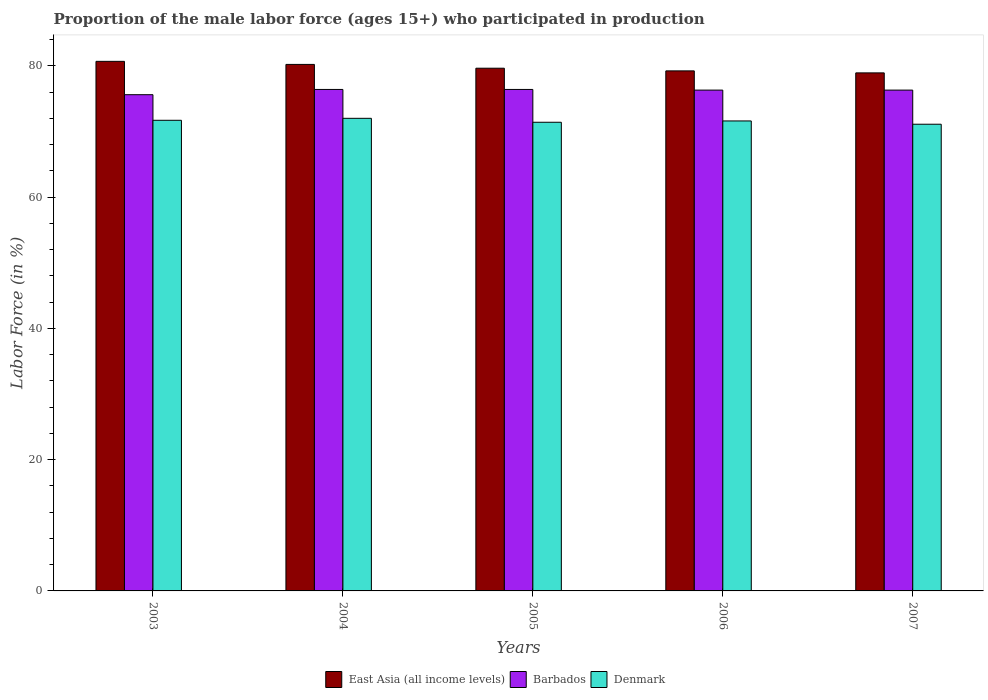How many different coloured bars are there?
Your response must be concise. 3. Are the number of bars per tick equal to the number of legend labels?
Provide a succinct answer. Yes. Are the number of bars on each tick of the X-axis equal?
Provide a succinct answer. Yes. How many bars are there on the 1st tick from the right?
Make the answer very short. 3. What is the label of the 1st group of bars from the left?
Keep it short and to the point. 2003. What is the proportion of the male labor force who participated in production in East Asia (all income levels) in 2004?
Offer a terse response. 80.21. Across all years, what is the maximum proportion of the male labor force who participated in production in East Asia (all income levels)?
Your response must be concise. 80.68. Across all years, what is the minimum proportion of the male labor force who participated in production in Denmark?
Offer a very short reply. 71.1. In which year was the proportion of the male labor force who participated in production in East Asia (all income levels) maximum?
Provide a succinct answer. 2003. What is the total proportion of the male labor force who participated in production in Barbados in the graph?
Your response must be concise. 381. What is the difference between the proportion of the male labor force who participated in production in East Asia (all income levels) in 2004 and that in 2005?
Your answer should be compact. 0.58. What is the difference between the proportion of the male labor force who participated in production in Denmark in 2003 and the proportion of the male labor force who participated in production in East Asia (all income levels) in 2006?
Your response must be concise. -7.53. What is the average proportion of the male labor force who participated in production in East Asia (all income levels) per year?
Give a very brief answer. 79.73. In the year 2004, what is the difference between the proportion of the male labor force who participated in production in East Asia (all income levels) and proportion of the male labor force who participated in production in Barbados?
Keep it short and to the point. 3.81. What is the ratio of the proportion of the male labor force who participated in production in East Asia (all income levels) in 2005 to that in 2007?
Provide a succinct answer. 1.01. Is the proportion of the male labor force who participated in production in East Asia (all income levels) in 2004 less than that in 2005?
Make the answer very short. No. What is the difference between the highest and the second highest proportion of the male labor force who participated in production in Barbados?
Your response must be concise. 0. What is the difference between the highest and the lowest proportion of the male labor force who participated in production in Barbados?
Provide a short and direct response. 0.8. Is the sum of the proportion of the male labor force who participated in production in East Asia (all income levels) in 2005 and 2007 greater than the maximum proportion of the male labor force who participated in production in Barbados across all years?
Give a very brief answer. Yes. How many years are there in the graph?
Provide a short and direct response. 5. Does the graph contain grids?
Give a very brief answer. No. Where does the legend appear in the graph?
Provide a succinct answer. Bottom center. How many legend labels are there?
Your response must be concise. 3. What is the title of the graph?
Provide a succinct answer. Proportion of the male labor force (ages 15+) who participated in production. What is the label or title of the Y-axis?
Keep it short and to the point. Labor Force (in %). What is the Labor Force (in %) of East Asia (all income levels) in 2003?
Keep it short and to the point. 80.68. What is the Labor Force (in %) of Barbados in 2003?
Provide a succinct answer. 75.6. What is the Labor Force (in %) of Denmark in 2003?
Give a very brief answer. 71.7. What is the Labor Force (in %) of East Asia (all income levels) in 2004?
Keep it short and to the point. 80.21. What is the Labor Force (in %) in Barbados in 2004?
Keep it short and to the point. 76.4. What is the Labor Force (in %) in Denmark in 2004?
Give a very brief answer. 72. What is the Labor Force (in %) in East Asia (all income levels) in 2005?
Provide a short and direct response. 79.63. What is the Labor Force (in %) in Barbados in 2005?
Your answer should be compact. 76.4. What is the Labor Force (in %) of Denmark in 2005?
Offer a terse response. 71.4. What is the Labor Force (in %) of East Asia (all income levels) in 2006?
Your answer should be compact. 79.23. What is the Labor Force (in %) in Barbados in 2006?
Make the answer very short. 76.3. What is the Labor Force (in %) in Denmark in 2006?
Your response must be concise. 71.6. What is the Labor Force (in %) of East Asia (all income levels) in 2007?
Offer a terse response. 78.92. What is the Labor Force (in %) of Barbados in 2007?
Ensure brevity in your answer.  76.3. What is the Labor Force (in %) in Denmark in 2007?
Ensure brevity in your answer.  71.1. Across all years, what is the maximum Labor Force (in %) in East Asia (all income levels)?
Offer a very short reply. 80.68. Across all years, what is the maximum Labor Force (in %) in Barbados?
Ensure brevity in your answer.  76.4. Across all years, what is the maximum Labor Force (in %) of Denmark?
Your response must be concise. 72. Across all years, what is the minimum Labor Force (in %) in East Asia (all income levels)?
Your answer should be compact. 78.92. Across all years, what is the minimum Labor Force (in %) of Barbados?
Your response must be concise. 75.6. Across all years, what is the minimum Labor Force (in %) of Denmark?
Keep it short and to the point. 71.1. What is the total Labor Force (in %) in East Asia (all income levels) in the graph?
Your answer should be compact. 398.67. What is the total Labor Force (in %) of Barbados in the graph?
Give a very brief answer. 381. What is the total Labor Force (in %) in Denmark in the graph?
Provide a short and direct response. 357.8. What is the difference between the Labor Force (in %) of East Asia (all income levels) in 2003 and that in 2004?
Ensure brevity in your answer.  0.47. What is the difference between the Labor Force (in %) of East Asia (all income levels) in 2003 and that in 2005?
Keep it short and to the point. 1.04. What is the difference between the Labor Force (in %) of Barbados in 2003 and that in 2005?
Your response must be concise. -0.8. What is the difference between the Labor Force (in %) of East Asia (all income levels) in 2003 and that in 2006?
Keep it short and to the point. 1.45. What is the difference between the Labor Force (in %) of Denmark in 2003 and that in 2006?
Your response must be concise. 0.1. What is the difference between the Labor Force (in %) of East Asia (all income levels) in 2003 and that in 2007?
Make the answer very short. 1.76. What is the difference between the Labor Force (in %) in East Asia (all income levels) in 2004 and that in 2005?
Offer a terse response. 0.58. What is the difference between the Labor Force (in %) in East Asia (all income levels) in 2004 and that in 2006?
Keep it short and to the point. 0.98. What is the difference between the Labor Force (in %) of Denmark in 2004 and that in 2006?
Ensure brevity in your answer.  0.4. What is the difference between the Labor Force (in %) of East Asia (all income levels) in 2004 and that in 2007?
Provide a succinct answer. 1.29. What is the difference between the Labor Force (in %) in Barbados in 2004 and that in 2007?
Your response must be concise. 0.1. What is the difference between the Labor Force (in %) of Denmark in 2004 and that in 2007?
Your answer should be compact. 0.9. What is the difference between the Labor Force (in %) of East Asia (all income levels) in 2005 and that in 2006?
Provide a short and direct response. 0.41. What is the difference between the Labor Force (in %) of Denmark in 2005 and that in 2006?
Ensure brevity in your answer.  -0.2. What is the difference between the Labor Force (in %) in East Asia (all income levels) in 2005 and that in 2007?
Provide a short and direct response. 0.71. What is the difference between the Labor Force (in %) of East Asia (all income levels) in 2006 and that in 2007?
Give a very brief answer. 0.31. What is the difference between the Labor Force (in %) of East Asia (all income levels) in 2003 and the Labor Force (in %) of Barbados in 2004?
Offer a very short reply. 4.28. What is the difference between the Labor Force (in %) of East Asia (all income levels) in 2003 and the Labor Force (in %) of Denmark in 2004?
Make the answer very short. 8.68. What is the difference between the Labor Force (in %) of East Asia (all income levels) in 2003 and the Labor Force (in %) of Barbados in 2005?
Provide a short and direct response. 4.28. What is the difference between the Labor Force (in %) in East Asia (all income levels) in 2003 and the Labor Force (in %) in Denmark in 2005?
Your response must be concise. 9.28. What is the difference between the Labor Force (in %) in Barbados in 2003 and the Labor Force (in %) in Denmark in 2005?
Provide a short and direct response. 4.2. What is the difference between the Labor Force (in %) in East Asia (all income levels) in 2003 and the Labor Force (in %) in Barbados in 2006?
Ensure brevity in your answer.  4.38. What is the difference between the Labor Force (in %) of East Asia (all income levels) in 2003 and the Labor Force (in %) of Denmark in 2006?
Keep it short and to the point. 9.08. What is the difference between the Labor Force (in %) of East Asia (all income levels) in 2003 and the Labor Force (in %) of Barbados in 2007?
Your answer should be compact. 4.38. What is the difference between the Labor Force (in %) of East Asia (all income levels) in 2003 and the Labor Force (in %) of Denmark in 2007?
Your answer should be very brief. 9.58. What is the difference between the Labor Force (in %) of East Asia (all income levels) in 2004 and the Labor Force (in %) of Barbados in 2005?
Ensure brevity in your answer.  3.81. What is the difference between the Labor Force (in %) in East Asia (all income levels) in 2004 and the Labor Force (in %) in Denmark in 2005?
Your response must be concise. 8.81. What is the difference between the Labor Force (in %) of East Asia (all income levels) in 2004 and the Labor Force (in %) of Barbados in 2006?
Your answer should be compact. 3.91. What is the difference between the Labor Force (in %) of East Asia (all income levels) in 2004 and the Labor Force (in %) of Denmark in 2006?
Provide a succinct answer. 8.61. What is the difference between the Labor Force (in %) of East Asia (all income levels) in 2004 and the Labor Force (in %) of Barbados in 2007?
Provide a short and direct response. 3.91. What is the difference between the Labor Force (in %) of East Asia (all income levels) in 2004 and the Labor Force (in %) of Denmark in 2007?
Offer a terse response. 9.11. What is the difference between the Labor Force (in %) in Barbados in 2004 and the Labor Force (in %) in Denmark in 2007?
Offer a terse response. 5.3. What is the difference between the Labor Force (in %) in East Asia (all income levels) in 2005 and the Labor Force (in %) in Barbados in 2006?
Your answer should be compact. 3.33. What is the difference between the Labor Force (in %) of East Asia (all income levels) in 2005 and the Labor Force (in %) of Denmark in 2006?
Provide a succinct answer. 8.03. What is the difference between the Labor Force (in %) of East Asia (all income levels) in 2005 and the Labor Force (in %) of Barbados in 2007?
Make the answer very short. 3.33. What is the difference between the Labor Force (in %) in East Asia (all income levels) in 2005 and the Labor Force (in %) in Denmark in 2007?
Your answer should be very brief. 8.53. What is the difference between the Labor Force (in %) of East Asia (all income levels) in 2006 and the Labor Force (in %) of Barbados in 2007?
Your response must be concise. 2.93. What is the difference between the Labor Force (in %) in East Asia (all income levels) in 2006 and the Labor Force (in %) in Denmark in 2007?
Provide a succinct answer. 8.13. What is the average Labor Force (in %) of East Asia (all income levels) per year?
Your answer should be very brief. 79.73. What is the average Labor Force (in %) in Barbados per year?
Offer a terse response. 76.2. What is the average Labor Force (in %) of Denmark per year?
Make the answer very short. 71.56. In the year 2003, what is the difference between the Labor Force (in %) in East Asia (all income levels) and Labor Force (in %) in Barbados?
Your answer should be very brief. 5.08. In the year 2003, what is the difference between the Labor Force (in %) in East Asia (all income levels) and Labor Force (in %) in Denmark?
Your answer should be compact. 8.98. In the year 2003, what is the difference between the Labor Force (in %) in Barbados and Labor Force (in %) in Denmark?
Provide a succinct answer. 3.9. In the year 2004, what is the difference between the Labor Force (in %) of East Asia (all income levels) and Labor Force (in %) of Barbados?
Keep it short and to the point. 3.81. In the year 2004, what is the difference between the Labor Force (in %) of East Asia (all income levels) and Labor Force (in %) of Denmark?
Offer a very short reply. 8.21. In the year 2005, what is the difference between the Labor Force (in %) in East Asia (all income levels) and Labor Force (in %) in Barbados?
Provide a short and direct response. 3.23. In the year 2005, what is the difference between the Labor Force (in %) of East Asia (all income levels) and Labor Force (in %) of Denmark?
Ensure brevity in your answer.  8.23. In the year 2005, what is the difference between the Labor Force (in %) of Barbados and Labor Force (in %) of Denmark?
Your response must be concise. 5. In the year 2006, what is the difference between the Labor Force (in %) of East Asia (all income levels) and Labor Force (in %) of Barbados?
Provide a short and direct response. 2.93. In the year 2006, what is the difference between the Labor Force (in %) of East Asia (all income levels) and Labor Force (in %) of Denmark?
Provide a succinct answer. 7.63. In the year 2006, what is the difference between the Labor Force (in %) in Barbados and Labor Force (in %) in Denmark?
Keep it short and to the point. 4.7. In the year 2007, what is the difference between the Labor Force (in %) in East Asia (all income levels) and Labor Force (in %) in Barbados?
Your response must be concise. 2.62. In the year 2007, what is the difference between the Labor Force (in %) of East Asia (all income levels) and Labor Force (in %) of Denmark?
Give a very brief answer. 7.82. In the year 2007, what is the difference between the Labor Force (in %) of Barbados and Labor Force (in %) of Denmark?
Keep it short and to the point. 5.2. What is the ratio of the Labor Force (in %) of East Asia (all income levels) in 2003 to that in 2005?
Provide a short and direct response. 1.01. What is the ratio of the Labor Force (in %) in East Asia (all income levels) in 2003 to that in 2006?
Your answer should be very brief. 1.02. What is the ratio of the Labor Force (in %) of Barbados in 2003 to that in 2006?
Keep it short and to the point. 0.99. What is the ratio of the Labor Force (in %) of Denmark in 2003 to that in 2006?
Provide a short and direct response. 1. What is the ratio of the Labor Force (in %) of East Asia (all income levels) in 2003 to that in 2007?
Offer a terse response. 1.02. What is the ratio of the Labor Force (in %) in Barbados in 2003 to that in 2007?
Your answer should be compact. 0.99. What is the ratio of the Labor Force (in %) of Denmark in 2003 to that in 2007?
Provide a succinct answer. 1.01. What is the ratio of the Labor Force (in %) of Denmark in 2004 to that in 2005?
Give a very brief answer. 1.01. What is the ratio of the Labor Force (in %) of East Asia (all income levels) in 2004 to that in 2006?
Your answer should be compact. 1.01. What is the ratio of the Labor Force (in %) in Denmark in 2004 to that in 2006?
Your response must be concise. 1.01. What is the ratio of the Labor Force (in %) in East Asia (all income levels) in 2004 to that in 2007?
Make the answer very short. 1.02. What is the ratio of the Labor Force (in %) in Denmark in 2004 to that in 2007?
Ensure brevity in your answer.  1.01. What is the ratio of the Labor Force (in %) in Barbados in 2005 to that in 2007?
Your response must be concise. 1. What is the ratio of the Labor Force (in %) of East Asia (all income levels) in 2006 to that in 2007?
Keep it short and to the point. 1. What is the ratio of the Labor Force (in %) of Barbados in 2006 to that in 2007?
Your answer should be compact. 1. What is the ratio of the Labor Force (in %) of Denmark in 2006 to that in 2007?
Provide a short and direct response. 1.01. What is the difference between the highest and the second highest Labor Force (in %) in East Asia (all income levels)?
Make the answer very short. 0.47. What is the difference between the highest and the second highest Labor Force (in %) of Barbados?
Give a very brief answer. 0. What is the difference between the highest and the lowest Labor Force (in %) in East Asia (all income levels)?
Your response must be concise. 1.76. 